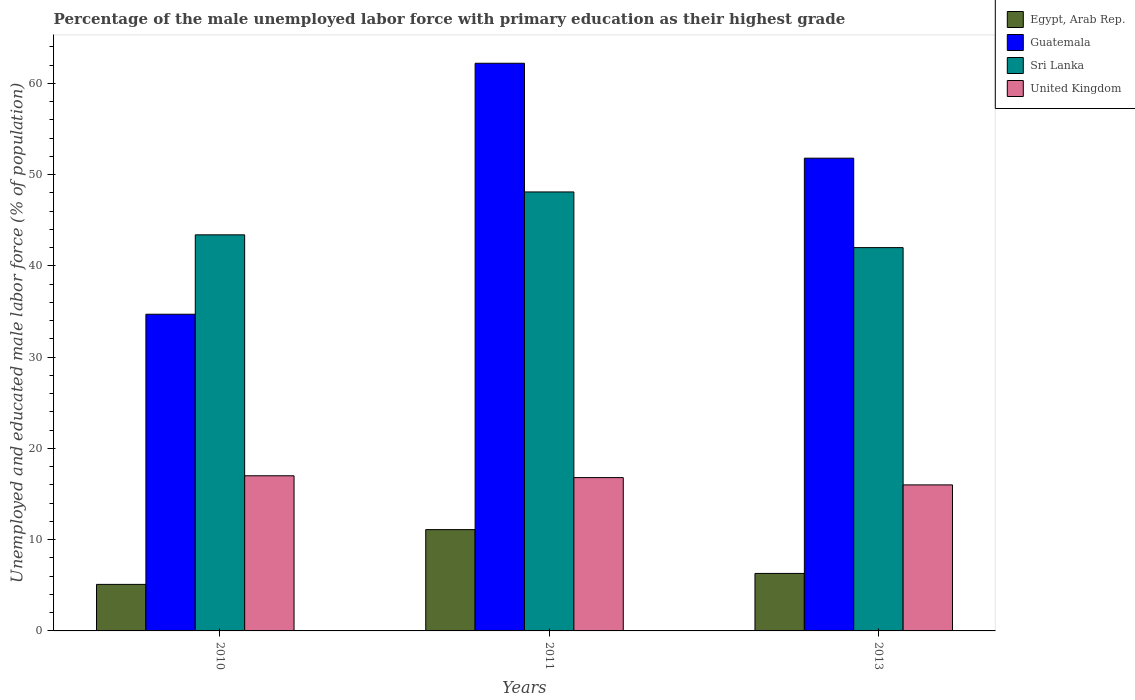How many different coloured bars are there?
Offer a very short reply. 4. How many groups of bars are there?
Your answer should be very brief. 3. Are the number of bars on each tick of the X-axis equal?
Your response must be concise. Yes. How many bars are there on the 1st tick from the left?
Offer a very short reply. 4. How many bars are there on the 2nd tick from the right?
Give a very brief answer. 4. In how many cases, is the number of bars for a given year not equal to the number of legend labels?
Provide a succinct answer. 0. Across all years, what is the minimum percentage of the unemployed male labor force with primary education in Egypt, Arab Rep.?
Provide a succinct answer. 5.1. In which year was the percentage of the unemployed male labor force with primary education in United Kingdom maximum?
Make the answer very short. 2010. What is the total percentage of the unemployed male labor force with primary education in Egypt, Arab Rep. in the graph?
Provide a short and direct response. 22.5. What is the difference between the percentage of the unemployed male labor force with primary education in Egypt, Arab Rep. in 2010 and that in 2013?
Offer a very short reply. -1.2. What is the average percentage of the unemployed male labor force with primary education in Guatemala per year?
Offer a terse response. 49.57. In the year 2010, what is the difference between the percentage of the unemployed male labor force with primary education in Guatemala and percentage of the unemployed male labor force with primary education in Sri Lanka?
Make the answer very short. -8.7. In how many years, is the percentage of the unemployed male labor force with primary education in Sri Lanka greater than 42 %?
Provide a succinct answer. 2. What is the ratio of the percentage of the unemployed male labor force with primary education in United Kingdom in 2010 to that in 2013?
Give a very brief answer. 1.06. Is the percentage of the unemployed male labor force with primary education in Sri Lanka in 2011 less than that in 2013?
Your answer should be compact. No. Is the difference between the percentage of the unemployed male labor force with primary education in Guatemala in 2011 and 2013 greater than the difference between the percentage of the unemployed male labor force with primary education in Sri Lanka in 2011 and 2013?
Your response must be concise. Yes. What is the difference between the highest and the second highest percentage of the unemployed male labor force with primary education in Guatemala?
Provide a short and direct response. 10.4. In how many years, is the percentage of the unemployed male labor force with primary education in Egypt, Arab Rep. greater than the average percentage of the unemployed male labor force with primary education in Egypt, Arab Rep. taken over all years?
Offer a terse response. 1. Is it the case that in every year, the sum of the percentage of the unemployed male labor force with primary education in United Kingdom and percentage of the unemployed male labor force with primary education in Sri Lanka is greater than the sum of percentage of the unemployed male labor force with primary education in Egypt, Arab Rep. and percentage of the unemployed male labor force with primary education in Guatemala?
Your answer should be very brief. No. What does the 2nd bar from the left in 2010 represents?
Keep it short and to the point. Guatemala. What does the 3rd bar from the right in 2010 represents?
Your response must be concise. Guatemala. Are all the bars in the graph horizontal?
Offer a very short reply. No. How many years are there in the graph?
Make the answer very short. 3. How many legend labels are there?
Provide a short and direct response. 4. How are the legend labels stacked?
Offer a terse response. Vertical. What is the title of the graph?
Your response must be concise. Percentage of the male unemployed labor force with primary education as their highest grade. What is the label or title of the X-axis?
Provide a succinct answer. Years. What is the label or title of the Y-axis?
Offer a terse response. Unemployed and educated male labor force (% of population). What is the Unemployed and educated male labor force (% of population) of Egypt, Arab Rep. in 2010?
Your answer should be very brief. 5.1. What is the Unemployed and educated male labor force (% of population) in Guatemala in 2010?
Your response must be concise. 34.7. What is the Unemployed and educated male labor force (% of population) in Sri Lanka in 2010?
Ensure brevity in your answer.  43.4. What is the Unemployed and educated male labor force (% of population) of United Kingdom in 2010?
Provide a short and direct response. 17. What is the Unemployed and educated male labor force (% of population) of Egypt, Arab Rep. in 2011?
Your answer should be very brief. 11.1. What is the Unemployed and educated male labor force (% of population) of Guatemala in 2011?
Your response must be concise. 62.2. What is the Unemployed and educated male labor force (% of population) of Sri Lanka in 2011?
Make the answer very short. 48.1. What is the Unemployed and educated male labor force (% of population) of United Kingdom in 2011?
Provide a short and direct response. 16.8. What is the Unemployed and educated male labor force (% of population) in Egypt, Arab Rep. in 2013?
Keep it short and to the point. 6.3. What is the Unemployed and educated male labor force (% of population) in Guatemala in 2013?
Offer a very short reply. 51.8. What is the Unemployed and educated male labor force (% of population) in Sri Lanka in 2013?
Your answer should be compact. 42. Across all years, what is the maximum Unemployed and educated male labor force (% of population) in Egypt, Arab Rep.?
Your answer should be very brief. 11.1. Across all years, what is the maximum Unemployed and educated male labor force (% of population) in Guatemala?
Offer a terse response. 62.2. Across all years, what is the maximum Unemployed and educated male labor force (% of population) of Sri Lanka?
Provide a short and direct response. 48.1. Across all years, what is the maximum Unemployed and educated male labor force (% of population) in United Kingdom?
Provide a succinct answer. 17. Across all years, what is the minimum Unemployed and educated male labor force (% of population) in Egypt, Arab Rep.?
Your answer should be very brief. 5.1. Across all years, what is the minimum Unemployed and educated male labor force (% of population) of Guatemala?
Your response must be concise. 34.7. Across all years, what is the minimum Unemployed and educated male labor force (% of population) in Sri Lanka?
Give a very brief answer. 42. Across all years, what is the minimum Unemployed and educated male labor force (% of population) of United Kingdom?
Your answer should be compact. 16. What is the total Unemployed and educated male labor force (% of population) in Guatemala in the graph?
Provide a succinct answer. 148.7. What is the total Unemployed and educated male labor force (% of population) of Sri Lanka in the graph?
Your answer should be compact. 133.5. What is the total Unemployed and educated male labor force (% of population) in United Kingdom in the graph?
Offer a terse response. 49.8. What is the difference between the Unemployed and educated male labor force (% of population) in Egypt, Arab Rep. in 2010 and that in 2011?
Offer a very short reply. -6. What is the difference between the Unemployed and educated male labor force (% of population) of Guatemala in 2010 and that in 2011?
Your answer should be compact. -27.5. What is the difference between the Unemployed and educated male labor force (% of population) of United Kingdom in 2010 and that in 2011?
Your response must be concise. 0.2. What is the difference between the Unemployed and educated male labor force (% of population) in Egypt, Arab Rep. in 2010 and that in 2013?
Provide a succinct answer. -1.2. What is the difference between the Unemployed and educated male labor force (% of population) in Guatemala in 2010 and that in 2013?
Offer a very short reply. -17.1. What is the difference between the Unemployed and educated male labor force (% of population) of United Kingdom in 2010 and that in 2013?
Your answer should be very brief. 1. What is the difference between the Unemployed and educated male labor force (% of population) of Egypt, Arab Rep. in 2011 and that in 2013?
Keep it short and to the point. 4.8. What is the difference between the Unemployed and educated male labor force (% of population) in United Kingdom in 2011 and that in 2013?
Keep it short and to the point. 0.8. What is the difference between the Unemployed and educated male labor force (% of population) of Egypt, Arab Rep. in 2010 and the Unemployed and educated male labor force (% of population) of Guatemala in 2011?
Keep it short and to the point. -57.1. What is the difference between the Unemployed and educated male labor force (% of population) in Egypt, Arab Rep. in 2010 and the Unemployed and educated male labor force (% of population) in Sri Lanka in 2011?
Your answer should be very brief. -43. What is the difference between the Unemployed and educated male labor force (% of population) in Guatemala in 2010 and the Unemployed and educated male labor force (% of population) in Sri Lanka in 2011?
Provide a short and direct response. -13.4. What is the difference between the Unemployed and educated male labor force (% of population) of Sri Lanka in 2010 and the Unemployed and educated male labor force (% of population) of United Kingdom in 2011?
Provide a short and direct response. 26.6. What is the difference between the Unemployed and educated male labor force (% of population) of Egypt, Arab Rep. in 2010 and the Unemployed and educated male labor force (% of population) of Guatemala in 2013?
Offer a terse response. -46.7. What is the difference between the Unemployed and educated male labor force (% of population) in Egypt, Arab Rep. in 2010 and the Unemployed and educated male labor force (% of population) in Sri Lanka in 2013?
Make the answer very short. -36.9. What is the difference between the Unemployed and educated male labor force (% of population) in Egypt, Arab Rep. in 2010 and the Unemployed and educated male labor force (% of population) in United Kingdom in 2013?
Your answer should be compact. -10.9. What is the difference between the Unemployed and educated male labor force (% of population) in Sri Lanka in 2010 and the Unemployed and educated male labor force (% of population) in United Kingdom in 2013?
Offer a very short reply. 27.4. What is the difference between the Unemployed and educated male labor force (% of population) of Egypt, Arab Rep. in 2011 and the Unemployed and educated male labor force (% of population) of Guatemala in 2013?
Give a very brief answer. -40.7. What is the difference between the Unemployed and educated male labor force (% of population) in Egypt, Arab Rep. in 2011 and the Unemployed and educated male labor force (% of population) in Sri Lanka in 2013?
Your answer should be compact. -30.9. What is the difference between the Unemployed and educated male labor force (% of population) of Guatemala in 2011 and the Unemployed and educated male labor force (% of population) of Sri Lanka in 2013?
Your response must be concise. 20.2. What is the difference between the Unemployed and educated male labor force (% of population) of Guatemala in 2011 and the Unemployed and educated male labor force (% of population) of United Kingdom in 2013?
Give a very brief answer. 46.2. What is the difference between the Unemployed and educated male labor force (% of population) of Sri Lanka in 2011 and the Unemployed and educated male labor force (% of population) of United Kingdom in 2013?
Provide a succinct answer. 32.1. What is the average Unemployed and educated male labor force (% of population) in Egypt, Arab Rep. per year?
Make the answer very short. 7.5. What is the average Unemployed and educated male labor force (% of population) in Guatemala per year?
Offer a terse response. 49.57. What is the average Unemployed and educated male labor force (% of population) in Sri Lanka per year?
Offer a very short reply. 44.5. In the year 2010, what is the difference between the Unemployed and educated male labor force (% of population) of Egypt, Arab Rep. and Unemployed and educated male labor force (% of population) of Guatemala?
Offer a terse response. -29.6. In the year 2010, what is the difference between the Unemployed and educated male labor force (% of population) of Egypt, Arab Rep. and Unemployed and educated male labor force (% of population) of Sri Lanka?
Give a very brief answer. -38.3. In the year 2010, what is the difference between the Unemployed and educated male labor force (% of population) of Egypt, Arab Rep. and Unemployed and educated male labor force (% of population) of United Kingdom?
Your answer should be very brief. -11.9. In the year 2010, what is the difference between the Unemployed and educated male labor force (% of population) of Guatemala and Unemployed and educated male labor force (% of population) of United Kingdom?
Offer a terse response. 17.7. In the year 2010, what is the difference between the Unemployed and educated male labor force (% of population) of Sri Lanka and Unemployed and educated male labor force (% of population) of United Kingdom?
Offer a terse response. 26.4. In the year 2011, what is the difference between the Unemployed and educated male labor force (% of population) of Egypt, Arab Rep. and Unemployed and educated male labor force (% of population) of Guatemala?
Your answer should be compact. -51.1. In the year 2011, what is the difference between the Unemployed and educated male labor force (% of population) of Egypt, Arab Rep. and Unemployed and educated male labor force (% of population) of Sri Lanka?
Your answer should be compact. -37. In the year 2011, what is the difference between the Unemployed and educated male labor force (% of population) in Egypt, Arab Rep. and Unemployed and educated male labor force (% of population) in United Kingdom?
Ensure brevity in your answer.  -5.7. In the year 2011, what is the difference between the Unemployed and educated male labor force (% of population) in Guatemala and Unemployed and educated male labor force (% of population) in United Kingdom?
Give a very brief answer. 45.4. In the year 2011, what is the difference between the Unemployed and educated male labor force (% of population) in Sri Lanka and Unemployed and educated male labor force (% of population) in United Kingdom?
Offer a very short reply. 31.3. In the year 2013, what is the difference between the Unemployed and educated male labor force (% of population) of Egypt, Arab Rep. and Unemployed and educated male labor force (% of population) of Guatemala?
Your answer should be very brief. -45.5. In the year 2013, what is the difference between the Unemployed and educated male labor force (% of population) in Egypt, Arab Rep. and Unemployed and educated male labor force (% of population) in Sri Lanka?
Keep it short and to the point. -35.7. In the year 2013, what is the difference between the Unemployed and educated male labor force (% of population) in Egypt, Arab Rep. and Unemployed and educated male labor force (% of population) in United Kingdom?
Your response must be concise. -9.7. In the year 2013, what is the difference between the Unemployed and educated male labor force (% of population) in Guatemala and Unemployed and educated male labor force (% of population) in United Kingdom?
Your response must be concise. 35.8. In the year 2013, what is the difference between the Unemployed and educated male labor force (% of population) in Sri Lanka and Unemployed and educated male labor force (% of population) in United Kingdom?
Make the answer very short. 26. What is the ratio of the Unemployed and educated male labor force (% of population) of Egypt, Arab Rep. in 2010 to that in 2011?
Your answer should be very brief. 0.46. What is the ratio of the Unemployed and educated male labor force (% of population) of Guatemala in 2010 to that in 2011?
Offer a very short reply. 0.56. What is the ratio of the Unemployed and educated male labor force (% of population) in Sri Lanka in 2010 to that in 2011?
Offer a very short reply. 0.9. What is the ratio of the Unemployed and educated male labor force (% of population) of United Kingdom in 2010 to that in 2011?
Make the answer very short. 1.01. What is the ratio of the Unemployed and educated male labor force (% of population) of Egypt, Arab Rep. in 2010 to that in 2013?
Offer a very short reply. 0.81. What is the ratio of the Unemployed and educated male labor force (% of population) in Guatemala in 2010 to that in 2013?
Give a very brief answer. 0.67. What is the ratio of the Unemployed and educated male labor force (% of population) in Egypt, Arab Rep. in 2011 to that in 2013?
Your answer should be very brief. 1.76. What is the ratio of the Unemployed and educated male labor force (% of population) in Guatemala in 2011 to that in 2013?
Ensure brevity in your answer.  1.2. What is the ratio of the Unemployed and educated male labor force (% of population) in Sri Lanka in 2011 to that in 2013?
Give a very brief answer. 1.15. What is the difference between the highest and the second highest Unemployed and educated male labor force (% of population) in Egypt, Arab Rep.?
Your answer should be very brief. 4.8. What is the difference between the highest and the second highest Unemployed and educated male labor force (% of population) in United Kingdom?
Ensure brevity in your answer.  0.2. What is the difference between the highest and the lowest Unemployed and educated male labor force (% of population) in Guatemala?
Offer a terse response. 27.5. What is the difference between the highest and the lowest Unemployed and educated male labor force (% of population) of Sri Lanka?
Ensure brevity in your answer.  6.1. 